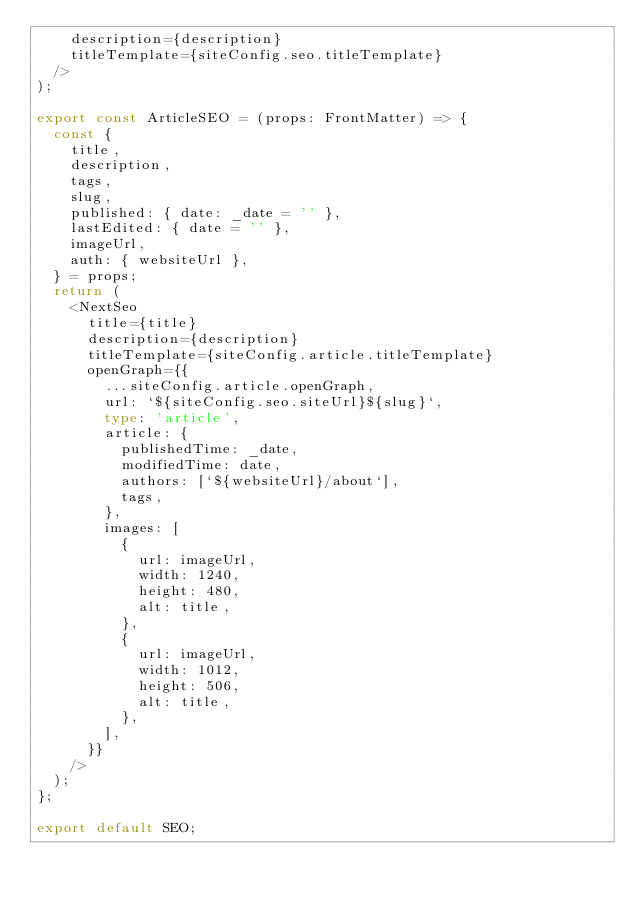Convert code to text. <code><loc_0><loc_0><loc_500><loc_500><_TypeScript_>    description={description}
    titleTemplate={siteConfig.seo.titleTemplate}
  />
);

export const ArticleSEO = (props: FrontMatter) => {
  const {
    title,
    description,
    tags,
    slug,
    published: { date: _date = '' },
    lastEdited: { date = '' },
    imageUrl,
    auth: { websiteUrl },
  } = props;
  return (
    <NextSeo
      title={title}
      description={description}
      titleTemplate={siteConfig.article.titleTemplate}
      openGraph={{
        ...siteConfig.article.openGraph,
        url: `${siteConfig.seo.siteUrl}${slug}`,
        type: 'article',
        article: {
          publishedTime: _date,
          modifiedTime: date,
          authors: [`${websiteUrl}/about`],
          tags,
        },
        images: [
          {
            url: imageUrl,
            width: 1240,
            height: 480,
            alt: title,
          },
          {
            url: imageUrl,
            width: 1012,
            height: 506,
            alt: title,
          },
        ],
      }}
    />
  );
};

export default SEO;
</code> 